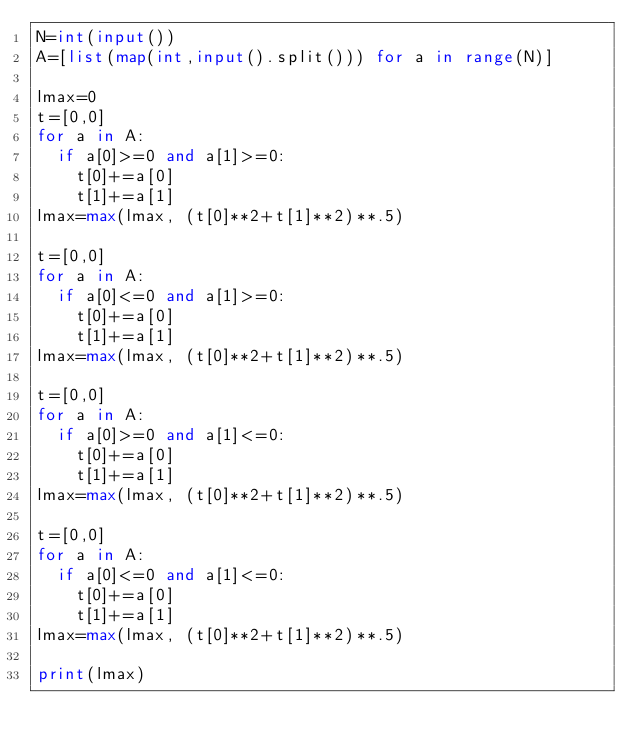Convert code to text. <code><loc_0><loc_0><loc_500><loc_500><_Python_>N=int(input())
A=[list(map(int,input().split())) for a in range(N)]

lmax=0
t=[0,0]
for a in A:
	if a[0]>=0 and a[1]>=0:
		t[0]+=a[0]
		t[1]+=a[1]
lmax=max(lmax, (t[0]**2+t[1]**2)**.5)

t=[0,0]
for a in A:
	if a[0]<=0 and a[1]>=0:
		t[0]+=a[0]
		t[1]+=a[1]
lmax=max(lmax, (t[0]**2+t[1]**2)**.5)

t=[0,0]
for a in A:
	if a[0]>=0 and a[1]<=0:
		t[0]+=a[0]
		t[1]+=a[1]
lmax=max(lmax, (t[0]**2+t[1]**2)**.5)

t=[0,0]
for a in A:
	if a[0]<=0 and a[1]<=0:
		t[0]+=a[0]
		t[1]+=a[1]
lmax=max(lmax, (t[0]**2+t[1]**2)**.5)

print(lmax)</code> 